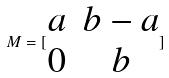<formula> <loc_0><loc_0><loc_500><loc_500>M = [ \begin{matrix} a & b - a \\ 0 & b \end{matrix} ]</formula> 